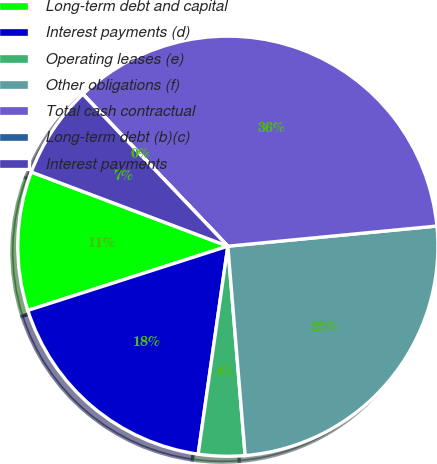Convert chart. <chart><loc_0><loc_0><loc_500><loc_500><pie_chart><fcel>Long-term debt and capital<fcel>Interest payments (d)<fcel>Operating leases (e)<fcel>Other obligations (f)<fcel>Total cash contractual<fcel>Long-term debt (b)(c)<fcel>Interest payments<nl><fcel>10.69%<fcel>17.8%<fcel>3.57%<fcel>25.22%<fcel>35.59%<fcel>0.01%<fcel>7.13%<nl></chart> 